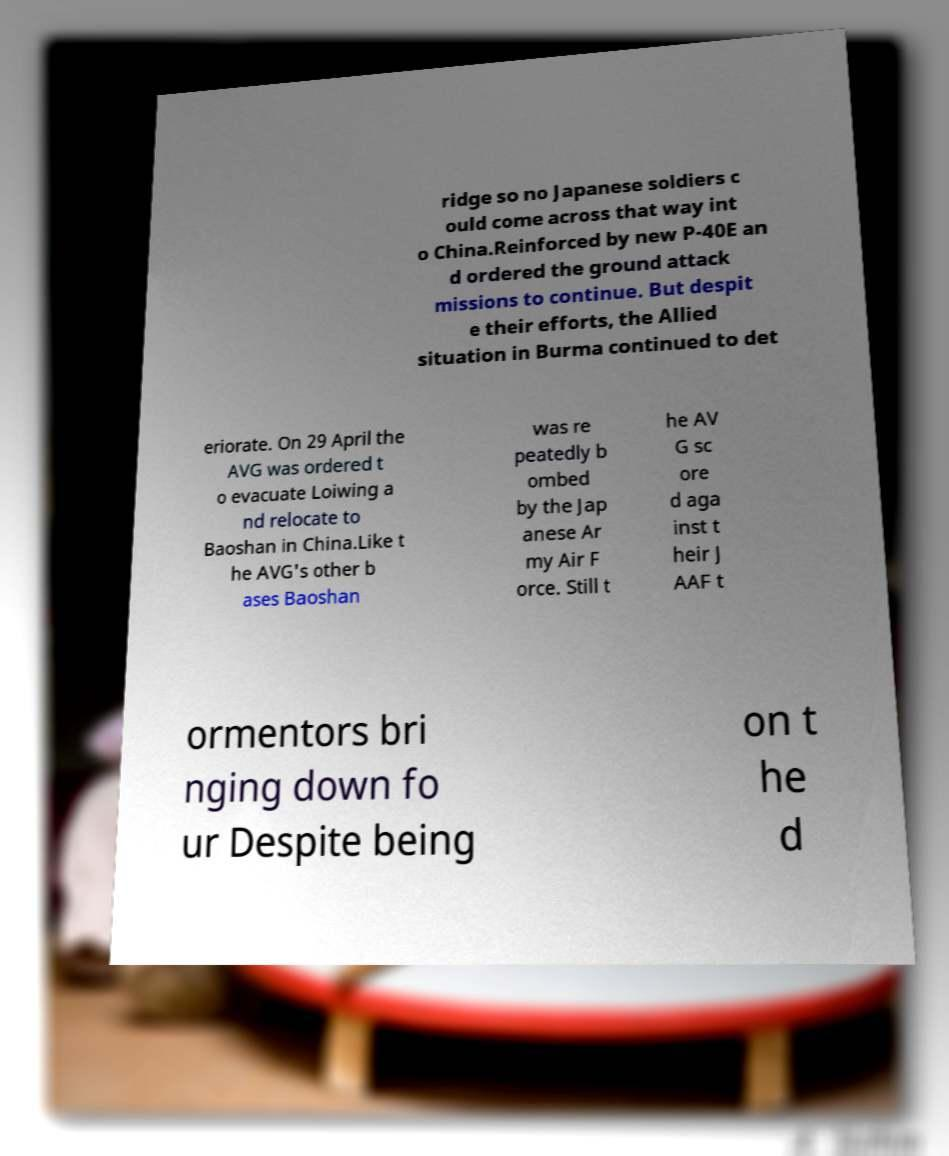Please identify and transcribe the text found in this image. ridge so no Japanese soldiers c ould come across that way int o China.Reinforced by new P-40E an d ordered the ground attack missions to continue. But despit e their efforts, the Allied situation in Burma continued to det eriorate. On 29 April the AVG was ordered t o evacuate Loiwing a nd relocate to Baoshan in China.Like t he AVG's other b ases Baoshan was re peatedly b ombed by the Jap anese Ar my Air F orce. Still t he AV G sc ore d aga inst t heir J AAF t ormentors bri nging down fo ur Despite being on t he d 